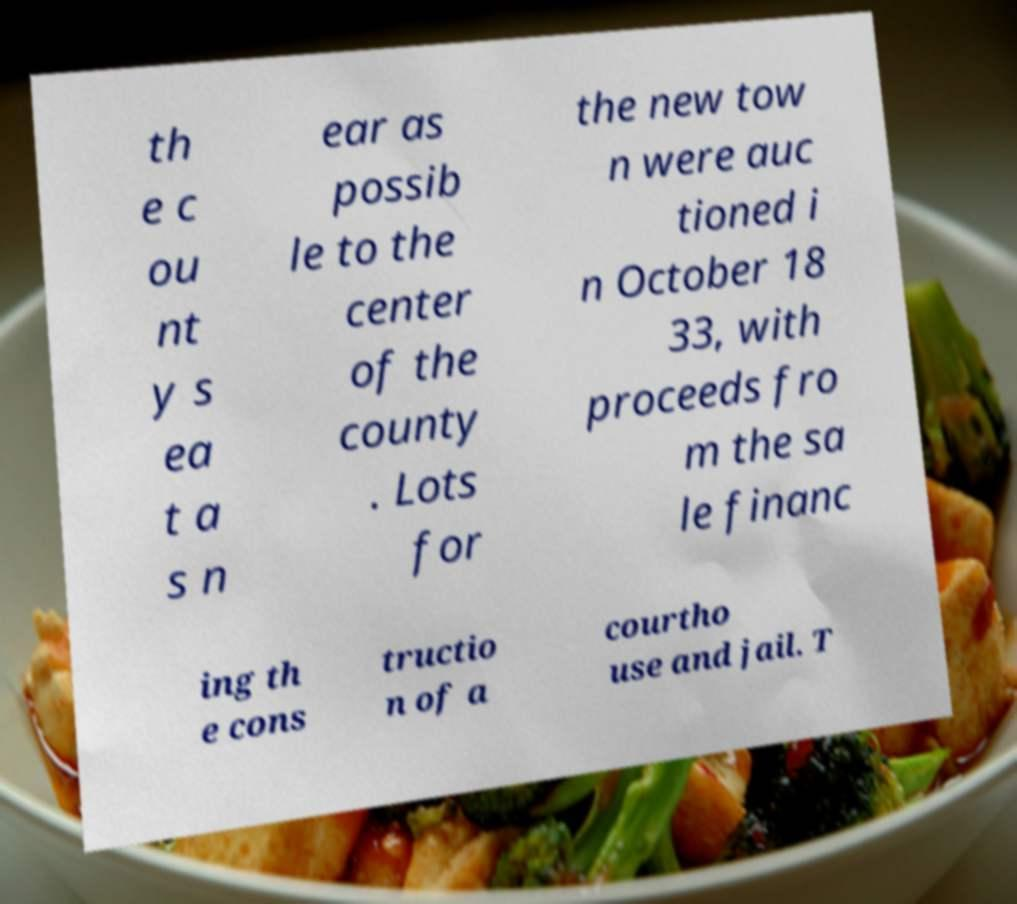Can you accurately transcribe the text from the provided image for me? th e c ou nt y s ea t a s n ear as possib le to the center of the county . Lots for the new tow n were auc tioned i n October 18 33, with proceeds fro m the sa le financ ing th e cons tructio n of a courtho use and jail. T 